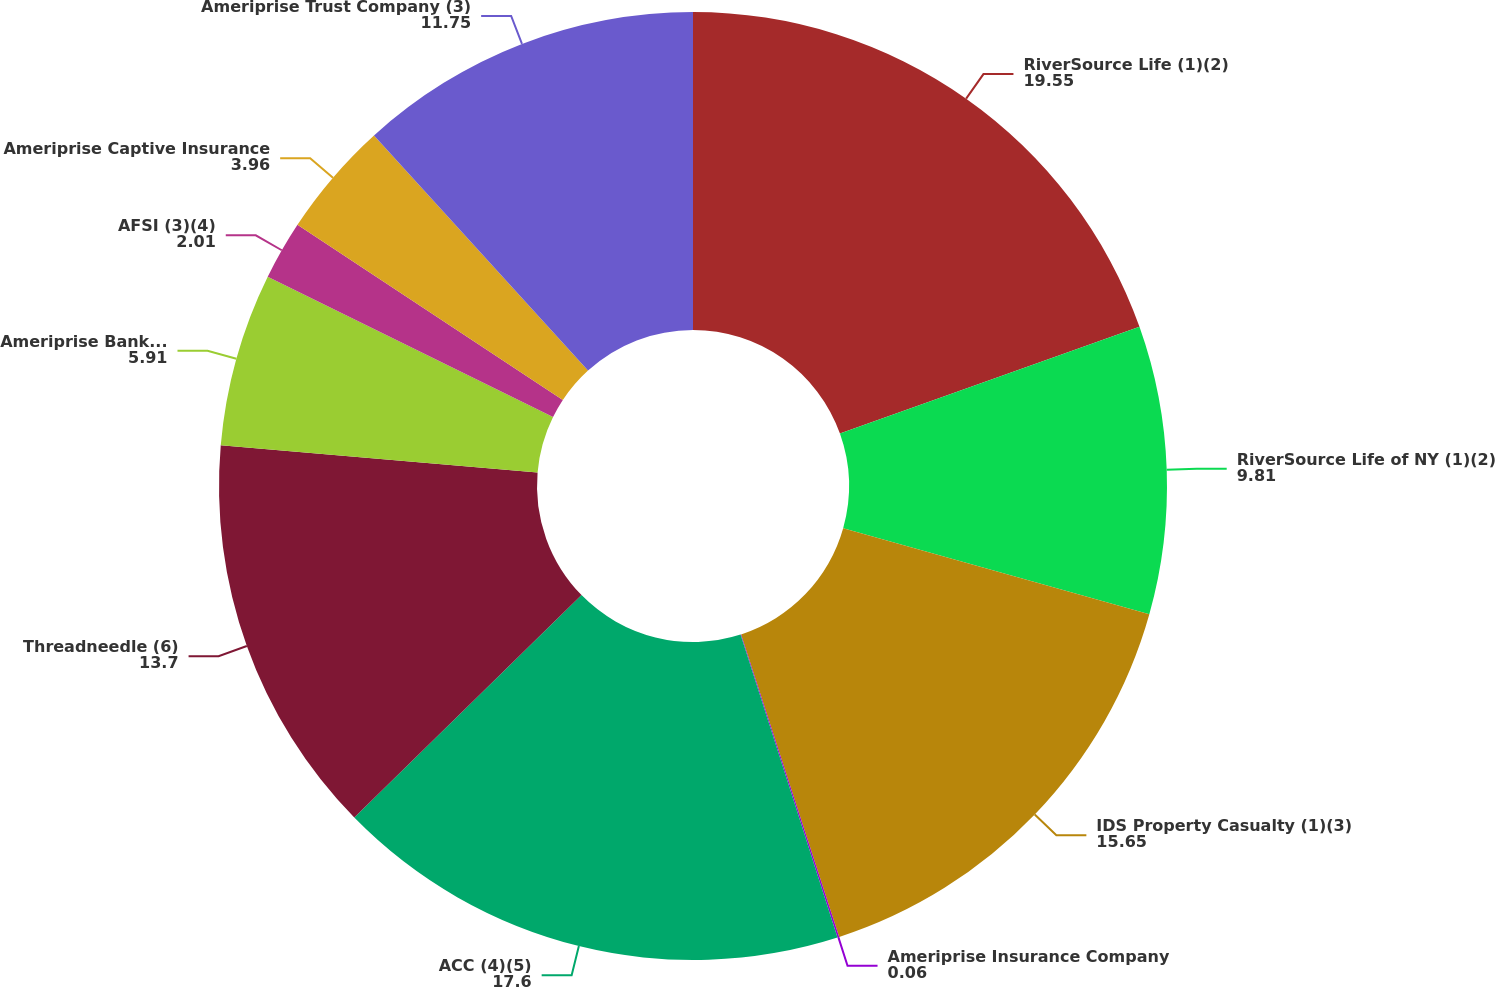<chart> <loc_0><loc_0><loc_500><loc_500><pie_chart><fcel>RiverSource Life (1)(2)<fcel>RiverSource Life of NY (1)(2)<fcel>IDS Property Casualty (1)(3)<fcel>Ameriprise Insurance Company<fcel>ACC (4)(5)<fcel>Threadneedle (6)<fcel>Ameriprise Bank FSB (7)<fcel>AFSI (3)(4)<fcel>Ameriprise Captive Insurance<fcel>Ameriprise Trust Company (3)<nl><fcel>19.55%<fcel>9.81%<fcel>15.65%<fcel>0.06%<fcel>17.6%<fcel>13.7%<fcel>5.91%<fcel>2.01%<fcel>3.96%<fcel>11.75%<nl></chart> 